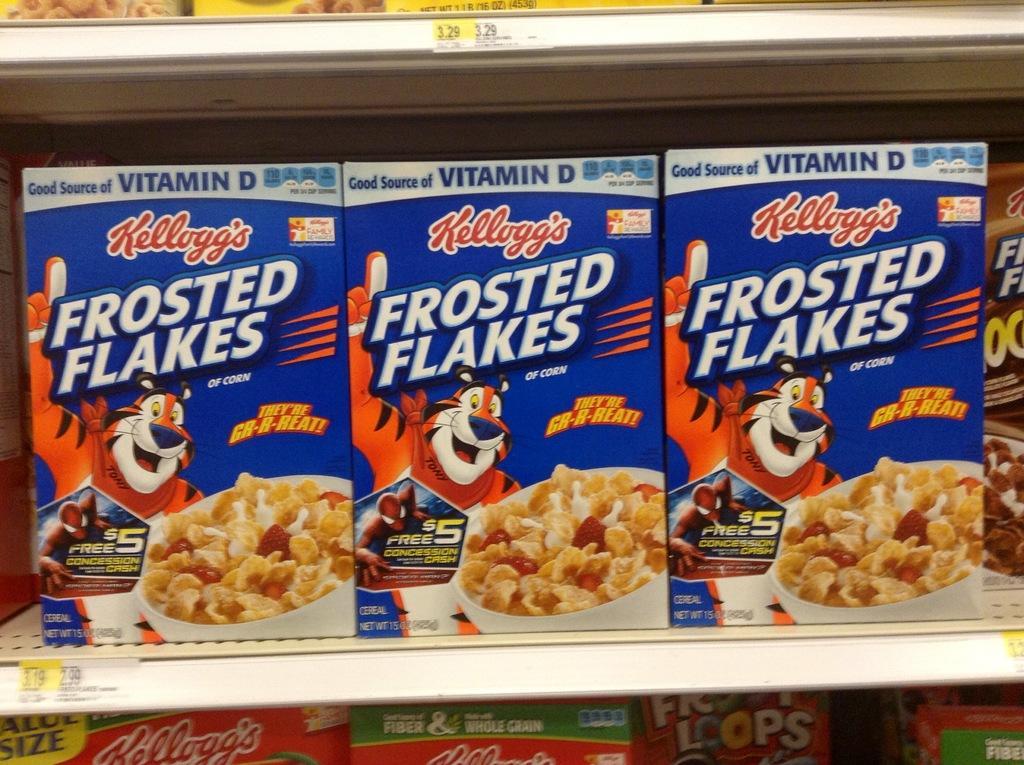Please provide a concise description of this image. In the foreground of this image, there are flakes boxes in the rack with the price tags on it. 